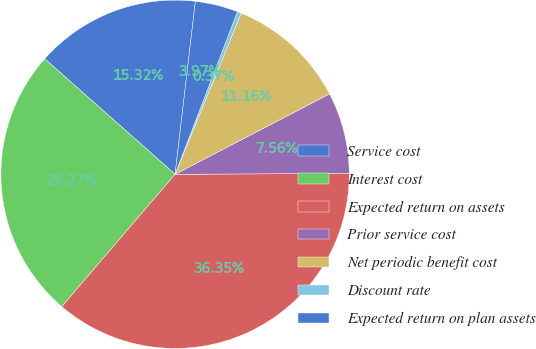Convert chart. <chart><loc_0><loc_0><loc_500><loc_500><pie_chart><fcel>Service cost<fcel>Interest cost<fcel>Expected return on assets<fcel>Prior service cost<fcel>Net periodic benefit cost<fcel>Discount rate<fcel>Expected return on plan assets<nl><fcel>15.32%<fcel>25.27%<fcel>36.35%<fcel>7.56%<fcel>11.16%<fcel>0.37%<fcel>3.97%<nl></chart> 